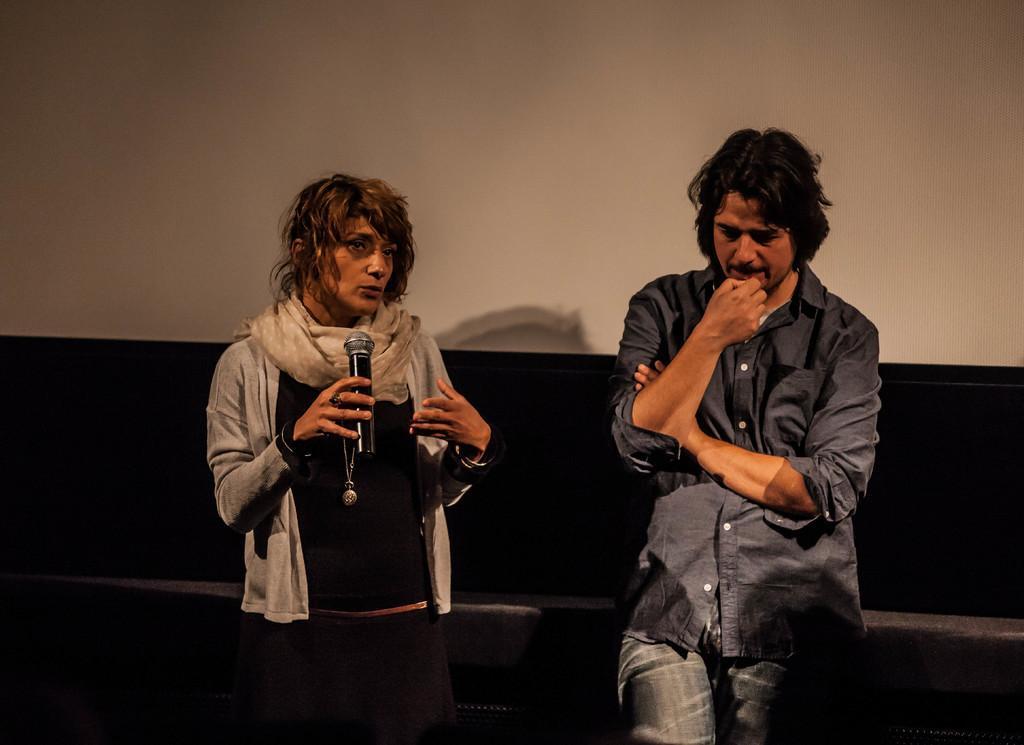How would you summarize this image in a sentence or two? In this image I can see a woman and a man are standing. I can see she is holding a mic. I can also see she is wearing a scarf. 